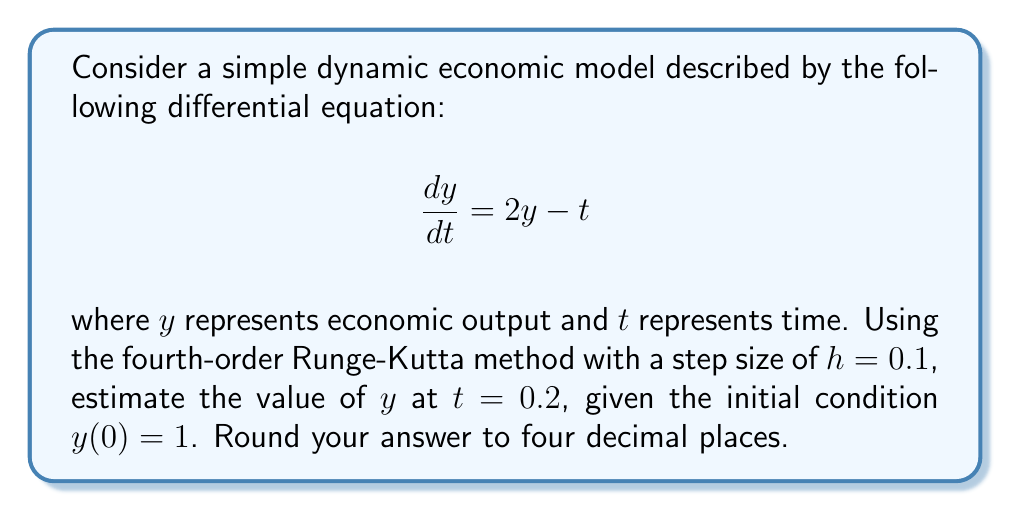Help me with this question. To solve this problem using the fourth-order Runge-Kutta method, we follow these steps:

1) The general form of the fourth-order Runge-Kutta method is:

   $y_{n+1} = y_n + \frac{1}{6}(k_1 + 2k_2 + 2k_3 + k_4)$

   where:
   $k_1 = hf(t_n, y_n)$
   $k_2 = hf(t_n + \frac{h}{2}, y_n + \frac{k_1}{2})$
   $k_3 = hf(t_n + \frac{h}{2}, y_n + \frac{k_2}{2})$
   $k_4 = hf(t_n + h, y_n + k_3)$

2) In our case, $f(t, y) = 2y - t$, $h = 0.1$, $t_0 = 0$, and $y_0 = 1$

3) We need to perform two iterations to reach $t = 0.2$

4) First iteration ($n = 0$):
   $k_1 = 0.1(2(1) - 0) = 0.2$
   $k_2 = 0.1(2(1 + 0.1) - 0.05) = 0.205$
   $k_3 = 0.1(2(1 + 0.1025) - 0.05) = 0.205$
   $k_4 = 0.1(2(1 + 0.205) - 0.1) = 0.21$

   $y_1 = 1 + \frac{1}{6}(0.2 + 2(0.205) + 2(0.205) + 0.21) = 1.2050$

5) Second iteration ($n = 1$):
   $k_1 = 0.1(2(1.2050) - 0.1) = 0.2310$
   $k_2 = 0.1(2(1.2050 + 0.1155) - 0.15) = 0.2316$
   $k_3 = 0.1(2(1.2050 + 0.1158) - 0.15) = 0.2316$
   $k_4 = 0.1(2(1.2050 + 0.2316) - 0.2) = 0.2322$

   $y_2 = 1.2050 + \frac{1}{6}(0.2310 + 2(0.2316) + 2(0.2316) + 0.2322) = 1.4366$

6) Therefore, the estimated value of $y$ at $t = 0.2$ is 1.4366.
Answer: 1.4366 